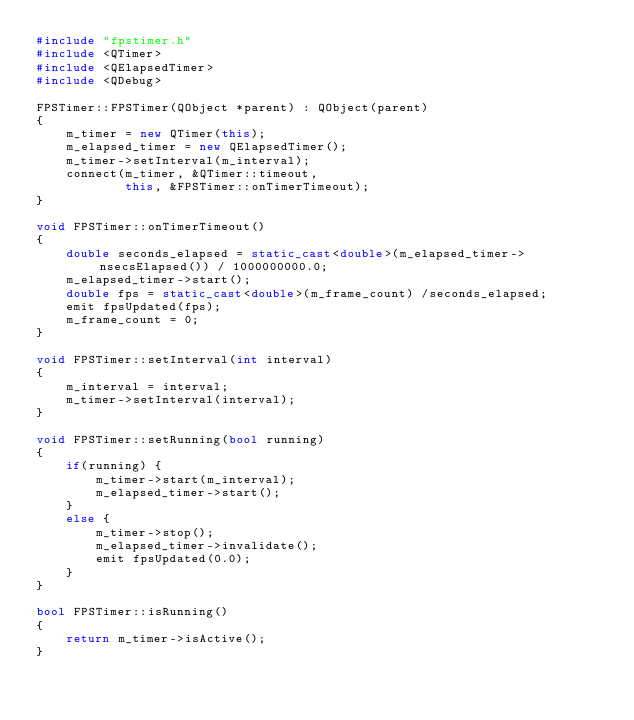<code> <loc_0><loc_0><loc_500><loc_500><_C++_>#include "fpstimer.h"
#include <QTimer>
#include <QElapsedTimer>
#include <QDebug>

FPSTimer::FPSTimer(QObject *parent) : QObject(parent)
{
    m_timer = new QTimer(this);
    m_elapsed_timer = new QElapsedTimer();
    m_timer->setInterval(m_interval);
    connect(m_timer, &QTimer::timeout,
            this, &FPSTimer::onTimerTimeout);
}

void FPSTimer::onTimerTimeout()
{
    double seconds_elapsed = static_cast<double>(m_elapsed_timer->nsecsElapsed()) / 1000000000.0;
    m_elapsed_timer->start();
    double fps = static_cast<double>(m_frame_count) /seconds_elapsed;
    emit fpsUpdated(fps);
    m_frame_count = 0;
}

void FPSTimer::setInterval(int interval)
{
    m_interval = interval;
    m_timer->setInterval(interval);
}

void FPSTimer::setRunning(bool running)
{
    if(running) {
        m_timer->start(m_interval);
        m_elapsed_timer->start();
    }
    else {
        m_timer->stop();
        m_elapsed_timer->invalidate();
        emit fpsUpdated(0.0);
    }
}

bool FPSTimer::isRunning()
{
    return m_timer->isActive();
}
</code> 